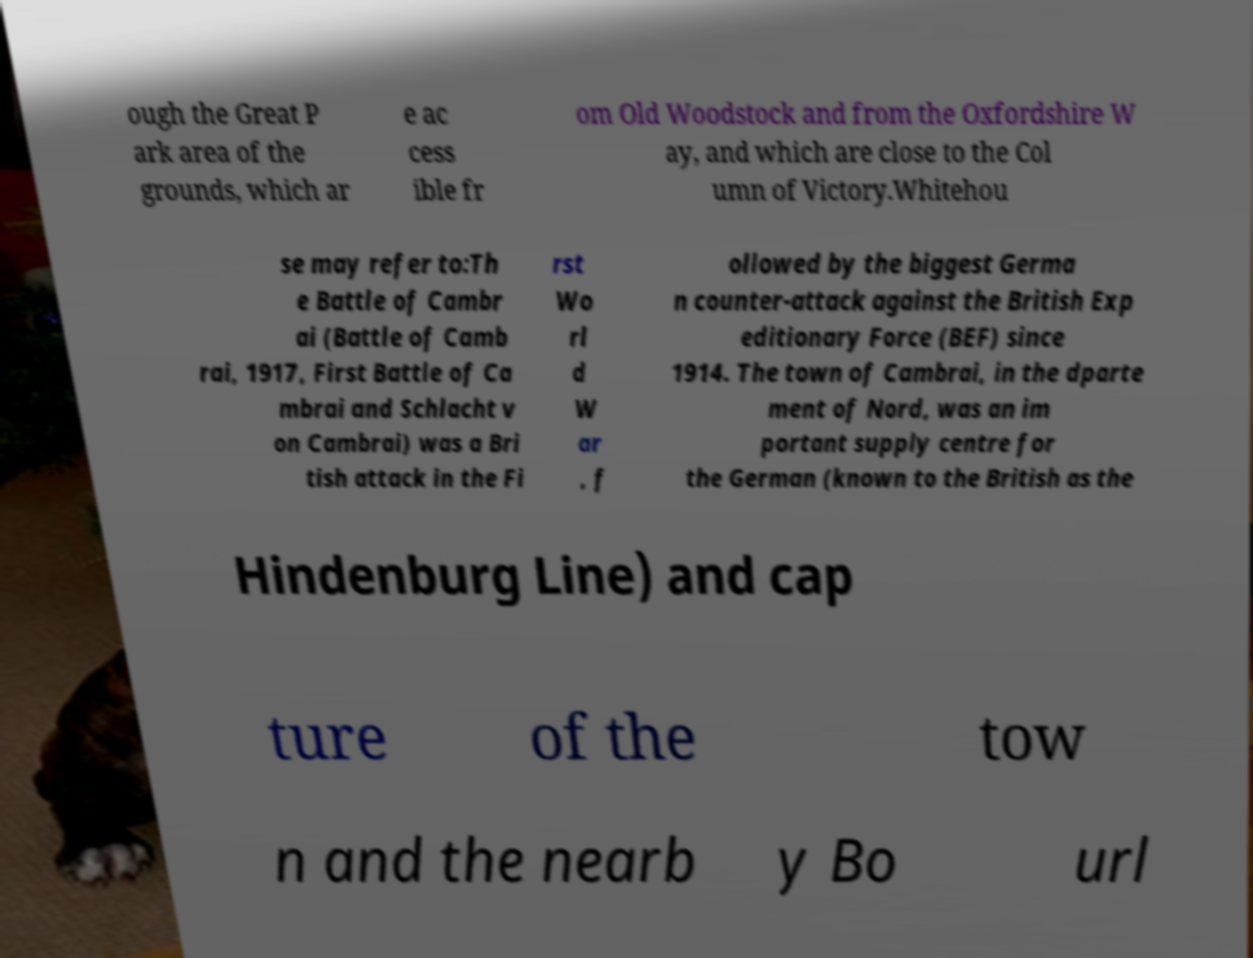Can you read and provide the text displayed in the image?This photo seems to have some interesting text. Can you extract and type it out for me? ough the Great P ark area of the grounds, which ar e ac cess ible fr om Old Woodstock and from the Oxfordshire W ay, and which are close to the Col umn of Victory.Whitehou se may refer to:Th e Battle of Cambr ai (Battle of Camb rai, 1917, First Battle of Ca mbrai and Schlacht v on Cambrai) was a Bri tish attack in the Fi rst Wo rl d W ar , f ollowed by the biggest Germa n counter-attack against the British Exp editionary Force (BEF) since 1914. The town of Cambrai, in the dparte ment of Nord, was an im portant supply centre for the German (known to the British as the Hindenburg Line) and cap ture of the tow n and the nearb y Bo url 